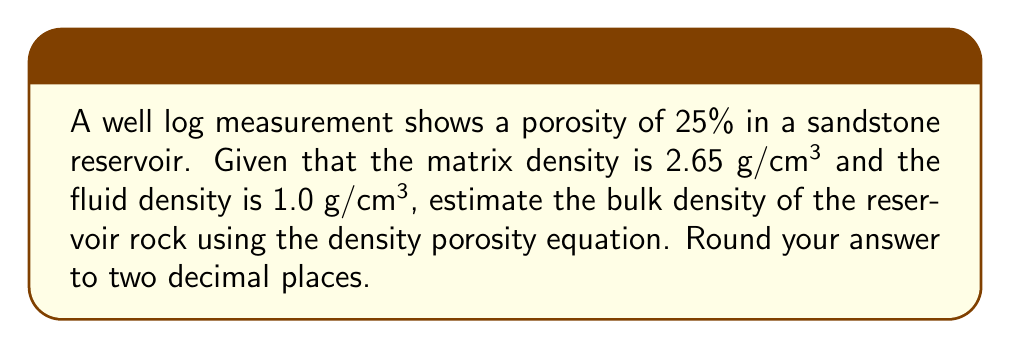Can you solve this math problem? To solve this problem, we'll use the density porosity equation, which relates porosity to the densities of the matrix, fluid, and bulk rock. The steps are as follows:

1. Recall the density porosity equation:
   $$\phi = \frac{\rho_{ma} - \rho_b}{\rho_{ma} - \rho_f}$$
   
   Where:
   $\phi$ = porosity
   $\rho_{ma}$ = matrix density
   $\rho_b$ = bulk density
   $\rho_f$ = fluid density

2. We are given:
   $\phi = 0.25$ (25% porosity)
   $\rho_{ma} = 2.65$ g/cm³
   $\rho_f = 1.0$ g/cm³
   
3. Rearrange the equation to solve for $\rho_b$:
   $$\rho_b = \rho_{ma} - \phi(\rho_{ma} - \rho_f)$$

4. Substitute the known values:
   $$\rho_b = 2.65 - 0.25(2.65 - 1.0)$$

5. Solve:
   $$\rho_b = 2.65 - 0.25(1.65)$$
   $$\rho_b = 2.65 - 0.4125$$
   $$\rho_b = 2.2375$$ g/cm³

6. Round to two decimal places:
   $$\rho_b \approx 2.24$$ g/cm³
Answer: 2.24 g/cm³ 